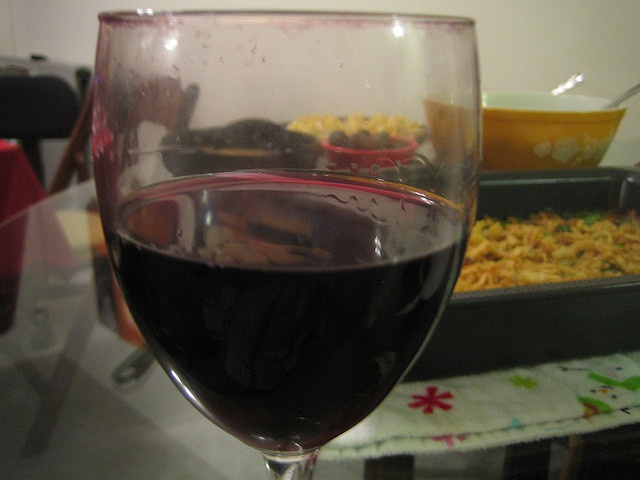Describe the objects in this image and their specific colors. I can see wine glass in darkgray, black, gray, maroon, and tan tones, dining table in darkgray, gray, and black tones, dining table in darkgray, gray, black, and darkgreen tones, bowl in darkgray, olive, and maroon tones, and bowl in darkgray, black, and gray tones in this image. 